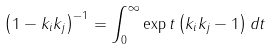Convert formula to latex. <formula><loc_0><loc_0><loc_500><loc_500>\left ( 1 - k _ { i } k _ { j } \right ) ^ { - 1 } = \int _ { 0 } ^ { \infty } \exp t \left ( k _ { i } k _ { j } - 1 \right ) d t</formula> 